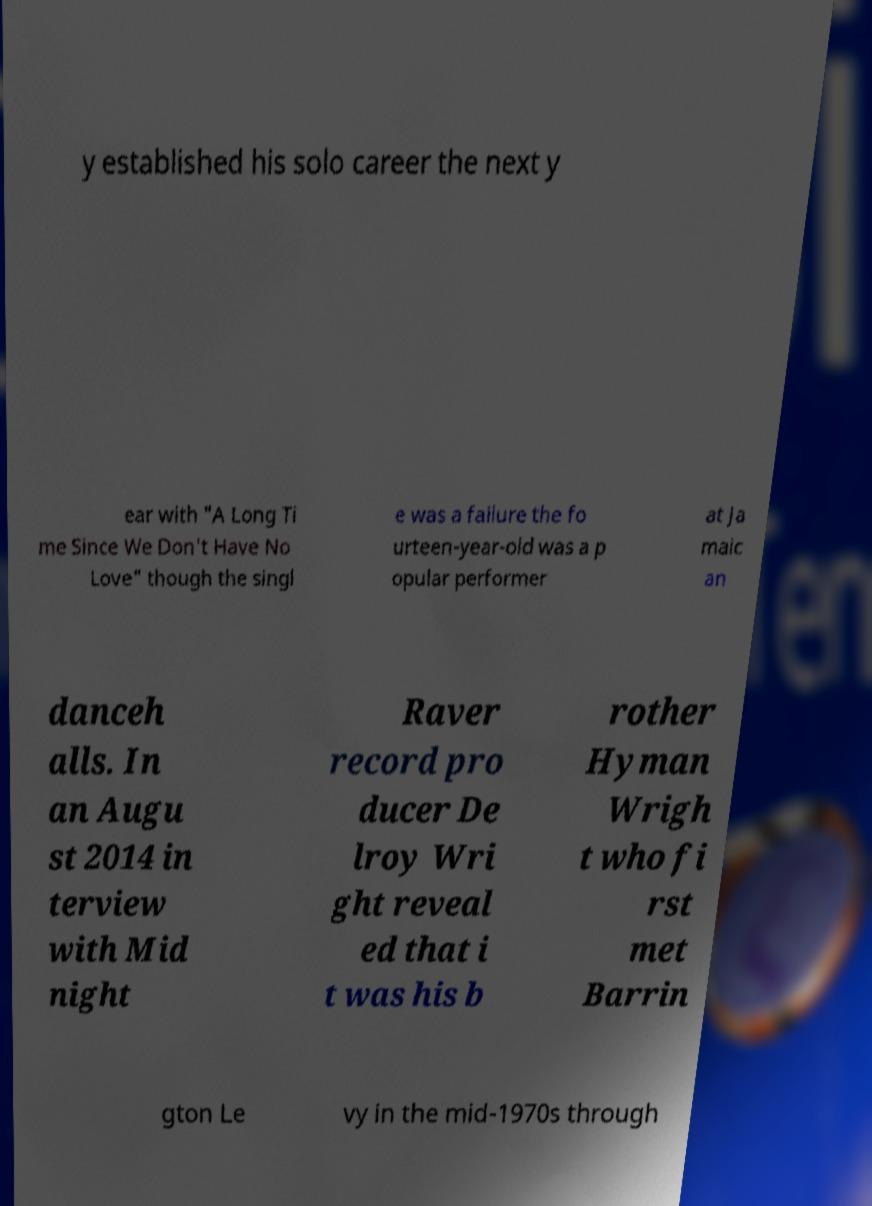Can you accurately transcribe the text from the provided image for me? y established his solo career the next y ear with "A Long Ti me Since We Don't Have No Love" though the singl e was a failure the fo urteen-year-old was a p opular performer at Ja maic an danceh alls. In an Augu st 2014 in terview with Mid night Raver record pro ducer De lroy Wri ght reveal ed that i t was his b rother Hyman Wrigh t who fi rst met Barrin gton Le vy in the mid-1970s through 